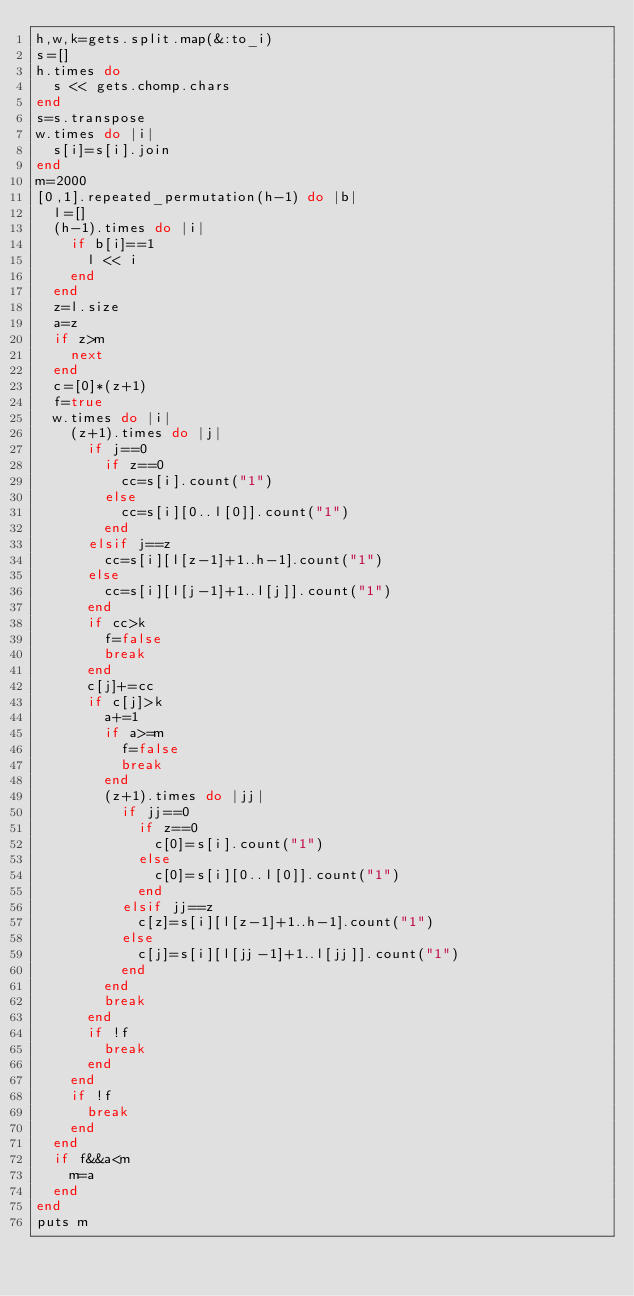Convert code to text. <code><loc_0><loc_0><loc_500><loc_500><_Ruby_>h,w,k=gets.split.map(&:to_i)
s=[]
h.times do
  s << gets.chomp.chars
end
s=s.transpose
w.times do |i|
  s[i]=s[i].join
end
m=2000
[0,1].repeated_permutation(h-1) do |b|
  l=[]
  (h-1).times do |i|
    if b[i]==1
      l << i
    end
  end
  z=l.size
  a=z
  if z>m
    next
  end
  c=[0]*(z+1)
  f=true
  w.times do |i|
    (z+1).times do |j|
      if j==0
        if z==0
          cc=s[i].count("1")
        else
          cc=s[i][0..l[0]].count("1")
        end
      elsif j==z
        cc=s[i][l[z-1]+1..h-1].count("1")
      else
        cc=s[i][l[j-1]+1..l[j]].count("1")
      end
      if cc>k
        f=false
        break
      end
      c[j]+=cc
      if c[j]>k
        a+=1
        if a>=m
          f=false
          break
        end
        (z+1).times do |jj|
          if jj==0
            if z==0
              c[0]=s[i].count("1")
            else
              c[0]=s[i][0..l[0]].count("1")
            end
          elsif jj==z
            c[z]=s[i][l[z-1]+1..h-1].count("1")
          else
            c[j]=s[i][l[jj-1]+1..l[jj]].count("1")
          end
        end
        break
      end
      if !f
        break
      end
    end
    if !f
      break
    end
  end
  if f&&a<m
    m=a
  end
end
puts m
</code> 